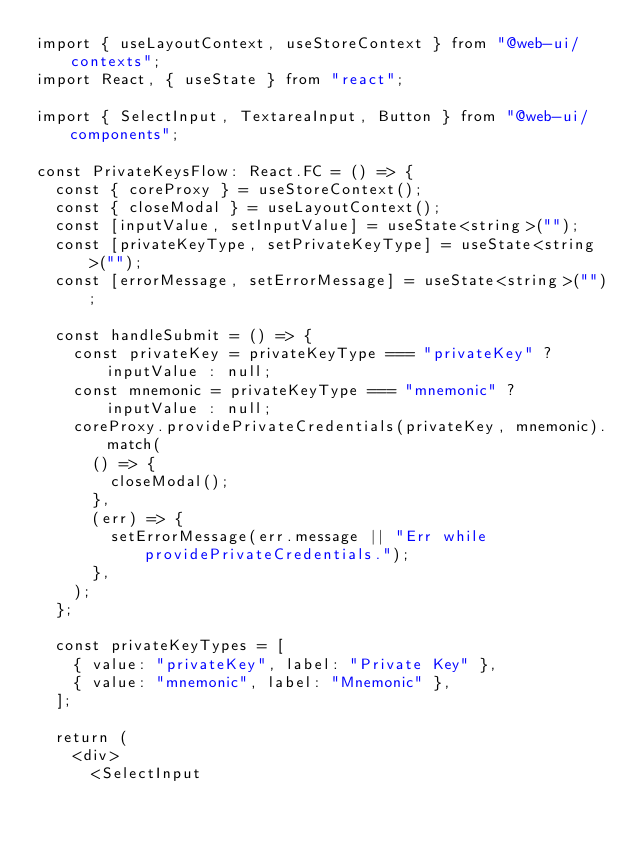<code> <loc_0><loc_0><loc_500><loc_500><_TypeScript_>import { useLayoutContext, useStoreContext } from "@web-ui/contexts";
import React, { useState } from "react";

import { SelectInput, TextareaInput, Button } from "@web-ui/components";

const PrivateKeysFlow: React.FC = () => {
  const { coreProxy } = useStoreContext();
  const { closeModal } = useLayoutContext();
  const [inputValue, setInputValue] = useState<string>("");
  const [privateKeyType, setPrivateKeyType] = useState<string>("");
  const [errorMessage, setErrorMessage] = useState<string>("");

  const handleSubmit = () => {
    const privateKey = privateKeyType === "privateKey" ? inputValue : null;
    const mnemonic = privateKeyType === "mnemonic" ? inputValue : null;
    coreProxy.providePrivateCredentials(privateKey, mnemonic).match(
      () => {
        closeModal();
      },
      (err) => {
        setErrorMessage(err.message || "Err while providePrivateCredentials.");
      },
    );
  };

  const privateKeyTypes = [
    { value: "privateKey", label: "Private Key" },
    { value: "mnemonic", label: "Mnemonic" },
  ];

  return (
    <div>
      <SelectInput</code> 